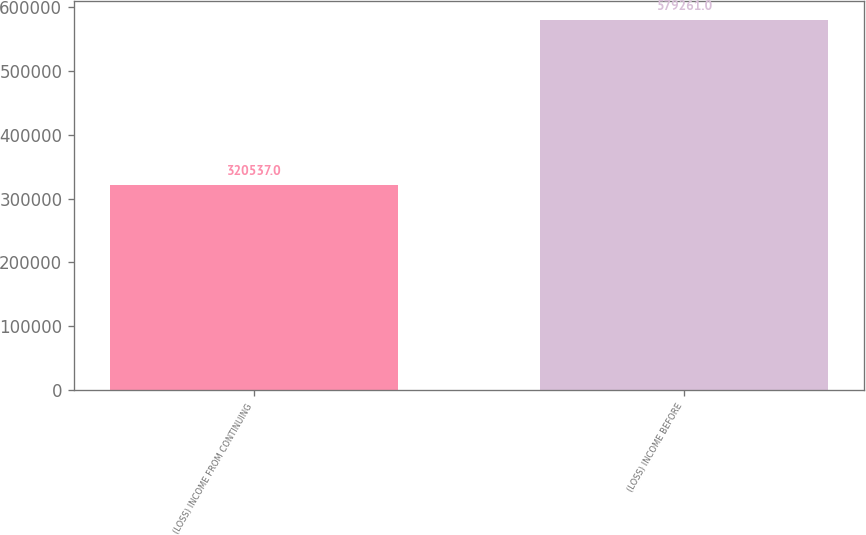Convert chart. <chart><loc_0><loc_0><loc_500><loc_500><bar_chart><fcel>(LOSS) INCOME FROM CONTINUING<fcel>(LOSS) INCOME BEFORE<nl><fcel>320537<fcel>579261<nl></chart> 